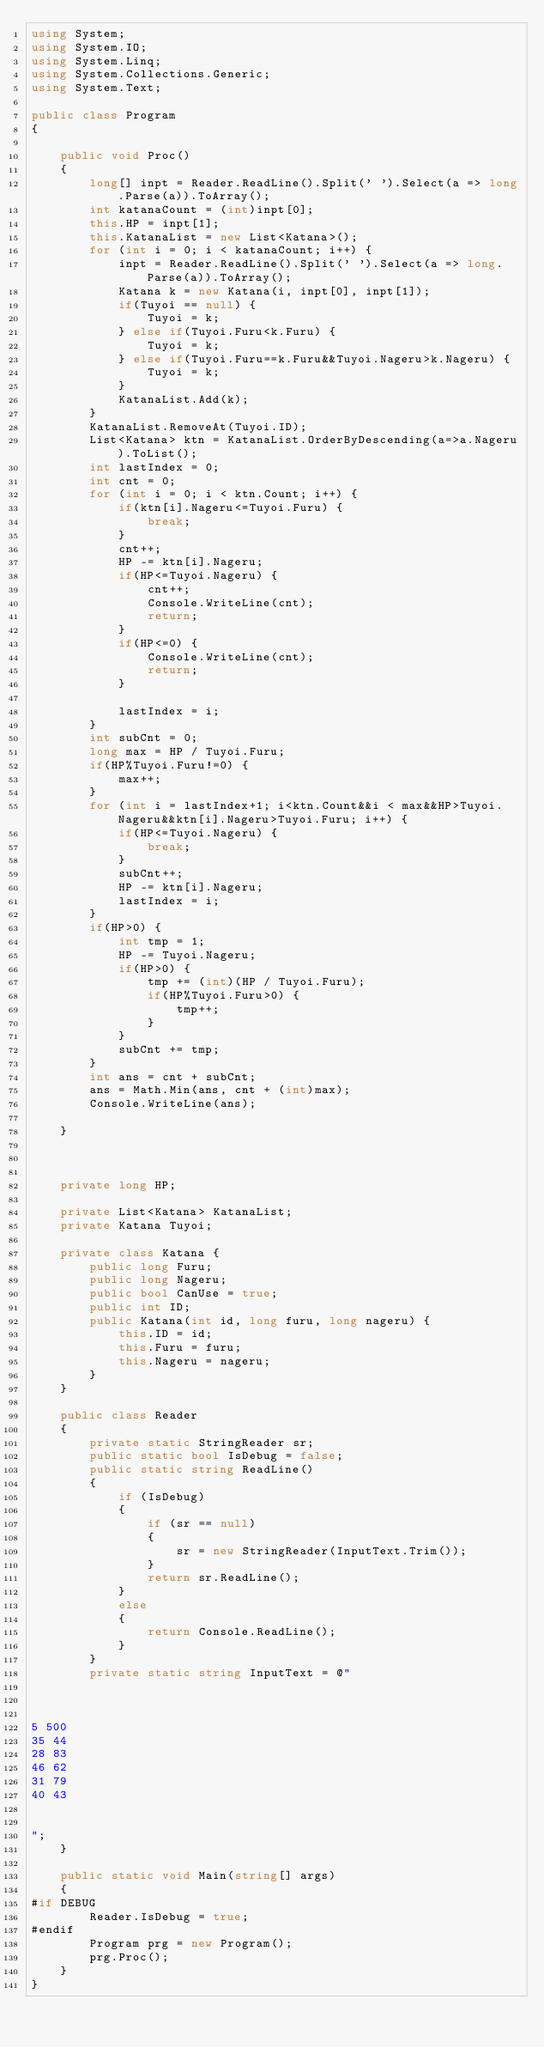Convert code to text. <code><loc_0><loc_0><loc_500><loc_500><_C#_>using System;
using System.IO;
using System.Linq;
using System.Collections.Generic;
using System.Text;

public class Program
{

    public void Proc()
    {
        long[] inpt = Reader.ReadLine().Split(' ').Select(a => long.Parse(a)).ToArray();
        int katanaCount = (int)inpt[0];
        this.HP = inpt[1];
        this.KatanaList = new List<Katana>();
        for (int i = 0; i < katanaCount; i++) {
            inpt = Reader.ReadLine().Split(' ').Select(a => long.Parse(a)).ToArray();
            Katana k = new Katana(i, inpt[0], inpt[1]);
            if(Tuyoi == null) {
                Tuyoi = k;
            } else if(Tuyoi.Furu<k.Furu) {
                Tuyoi = k;
            } else if(Tuyoi.Furu==k.Furu&&Tuyoi.Nageru>k.Nageru) {
                Tuyoi = k;
            }
            KatanaList.Add(k);
        }
        KatanaList.RemoveAt(Tuyoi.ID);
        List<Katana> ktn = KatanaList.OrderByDescending(a=>a.Nageru).ToList();
        int lastIndex = 0;
        int cnt = 0;
        for (int i = 0; i < ktn.Count; i++) {
            if(ktn[i].Nageru<=Tuyoi.Furu) {
                break;
            }
            cnt++;
            HP -= ktn[i].Nageru;
            if(HP<=Tuyoi.Nageru) {
                cnt++;
                Console.WriteLine(cnt);
                return;
            }
            if(HP<=0) {
                Console.WriteLine(cnt);
                return;
            }

            lastIndex = i;
        }
        int subCnt = 0;
        long max = HP / Tuyoi.Furu;
        if(HP%Tuyoi.Furu!=0) {
            max++;
        }
        for (int i = lastIndex+1; i<ktn.Count&&i < max&&HP>Tuyoi.Nageru&&ktn[i].Nageru>Tuyoi.Furu; i++) {
            if(HP<=Tuyoi.Nageru) {
                break;
            }
            subCnt++;
            HP -= ktn[i].Nageru;
            lastIndex = i;
        }
        if(HP>0) {
            int tmp = 1;
            HP -= Tuyoi.Nageru;
            if(HP>0) {
                tmp += (int)(HP / Tuyoi.Furu);
                if(HP%Tuyoi.Furu>0) {
                    tmp++;
                }
            }
            subCnt += tmp;
        }
        int ans = cnt + subCnt;
        ans = Math.Min(ans, cnt + (int)max);
        Console.WriteLine(ans);

    }



    private long HP;

    private List<Katana> KatanaList;
    private Katana Tuyoi;

    private class Katana {
        public long Furu;
        public long Nageru;
        public bool CanUse = true;
        public int ID;
        public Katana(int id, long furu, long nageru) {
            this.ID = id;
            this.Furu = furu;
            this.Nageru = nageru;
        }
    }

    public class Reader
    {
        private static StringReader sr;
        public static bool IsDebug = false;
        public static string ReadLine()
        {
            if (IsDebug)
            {
                if (sr == null)
                {
                    sr = new StringReader(InputText.Trim());
                }
                return sr.ReadLine();
            }
            else
            {
                return Console.ReadLine();
            }
        }
        private static string InputText = @"



5 500
35 44
28 83
46 62
31 79
40 43


";
    }

    public static void Main(string[] args)
    {
#if DEBUG
        Reader.IsDebug = true;
#endif
        Program prg = new Program();
        prg.Proc();
    }
}
</code> 